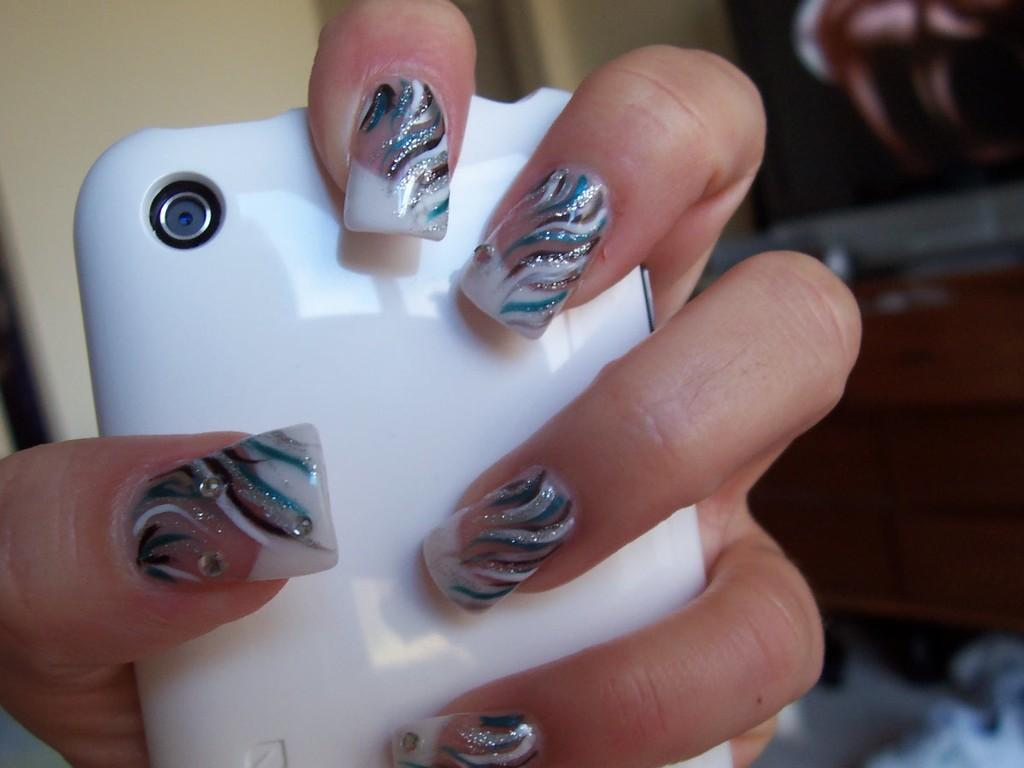What is the main subject of the image? There is a person in the image. What is the person holding in the image? The person is holding a cellphone. Can you describe the background of the image? The background of the image is blurry. What type of teeth can be seen in the image? There are no teeth visible in the image, as it features a person holding a cellphone with a blurry background. 